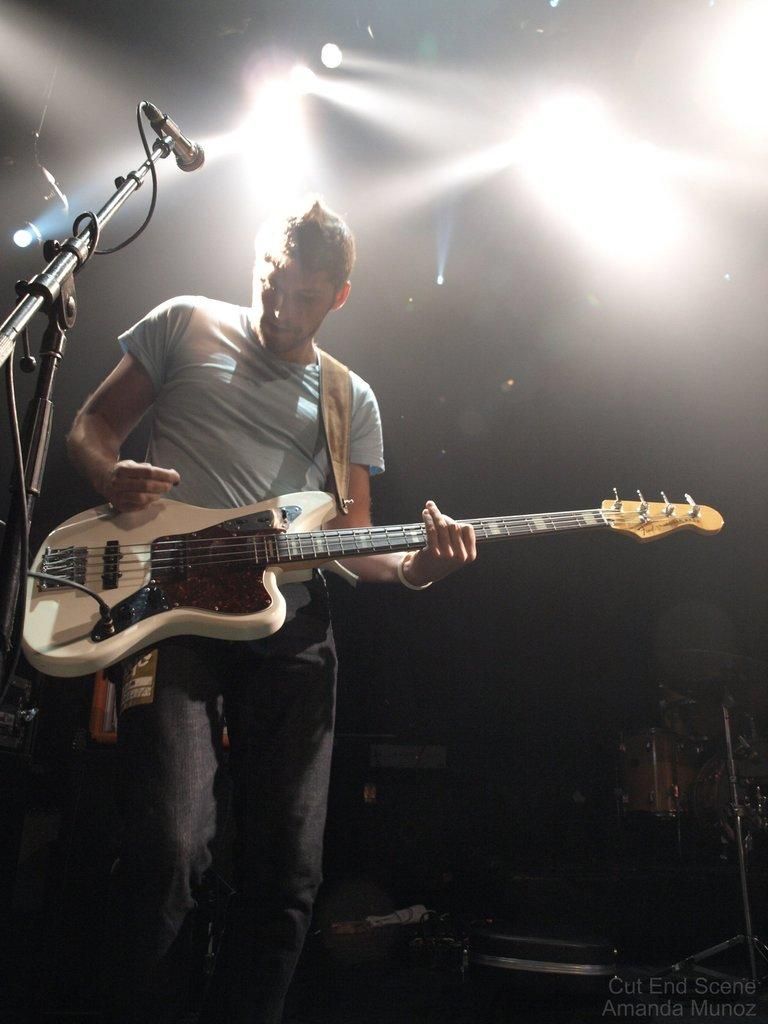What is the main subject of the image? The main subject of the image is a man. What is the man holding in his hand? The man is holding a guitar in his hand. What type of mint is growing in the image? There is no mint present in the image. Is the man playing the guitar in the rain? The image does not show any rain, so it cannot be determined if the man is playing the guitar in the rain. 